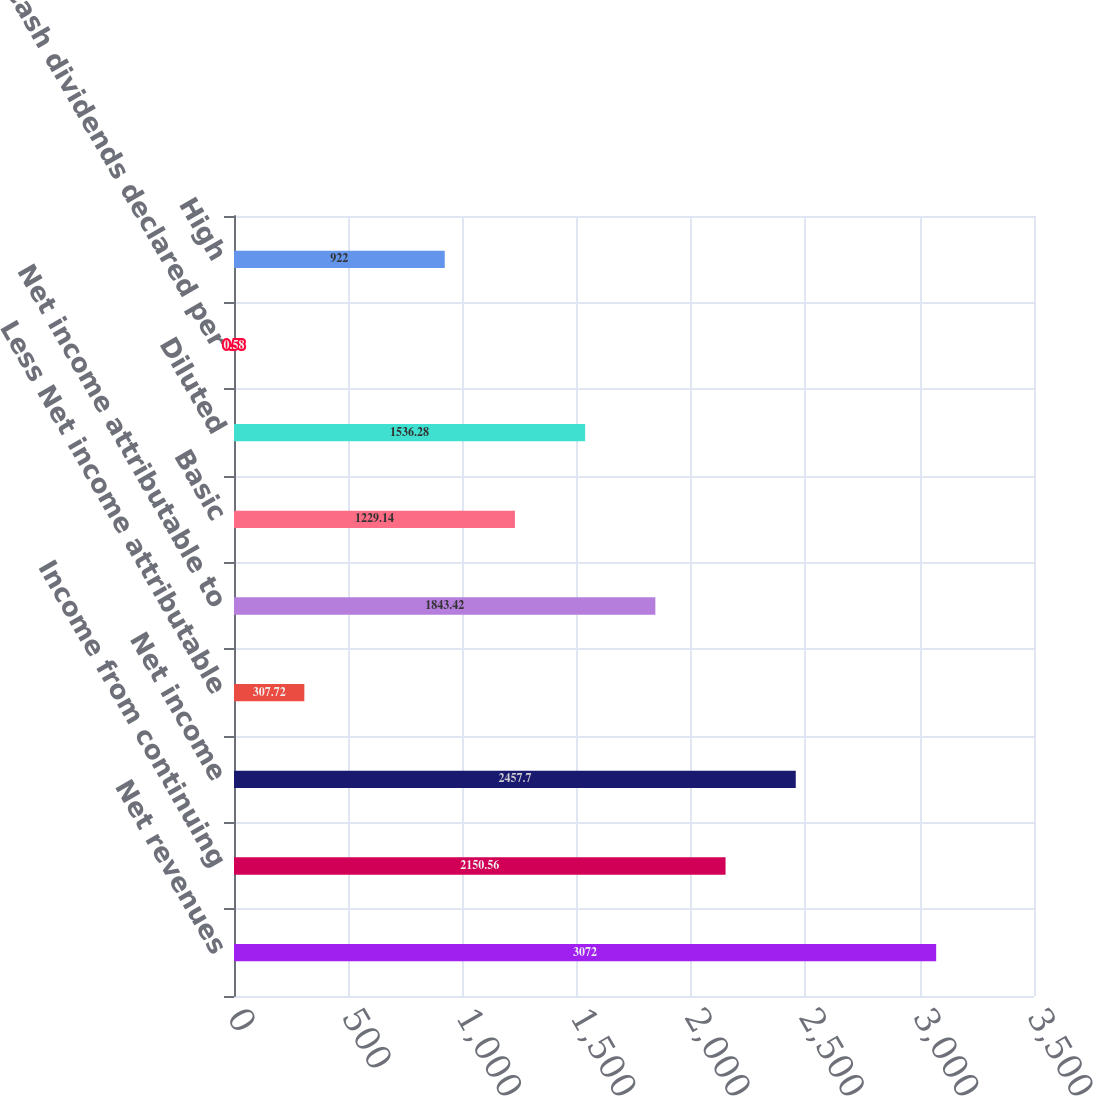Convert chart to OTSL. <chart><loc_0><loc_0><loc_500><loc_500><bar_chart><fcel>Net revenues<fcel>Income from continuing<fcel>Net income<fcel>Less Net income attributable<fcel>Net income attributable to<fcel>Basic<fcel>Diluted<fcel>Cash dividends declared per<fcel>High<nl><fcel>3072<fcel>2150.56<fcel>2457.7<fcel>307.72<fcel>1843.42<fcel>1229.14<fcel>1536.28<fcel>0.58<fcel>922<nl></chart> 